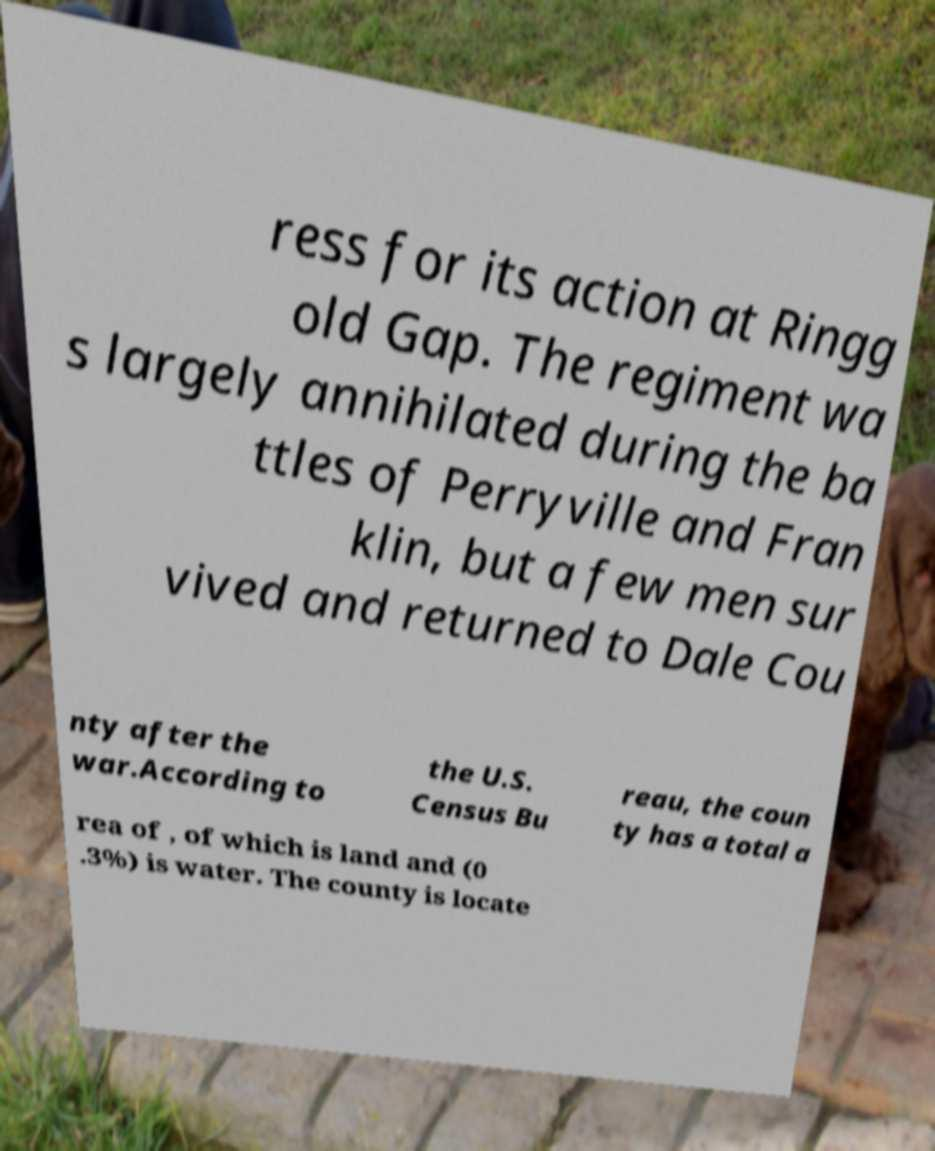Could you extract and type out the text from this image? ress for its action at Ringg old Gap. The regiment wa s largely annihilated during the ba ttles of Perryville and Fran klin, but a few men sur vived and returned to Dale Cou nty after the war.According to the U.S. Census Bu reau, the coun ty has a total a rea of , of which is land and (0 .3%) is water. The county is locate 